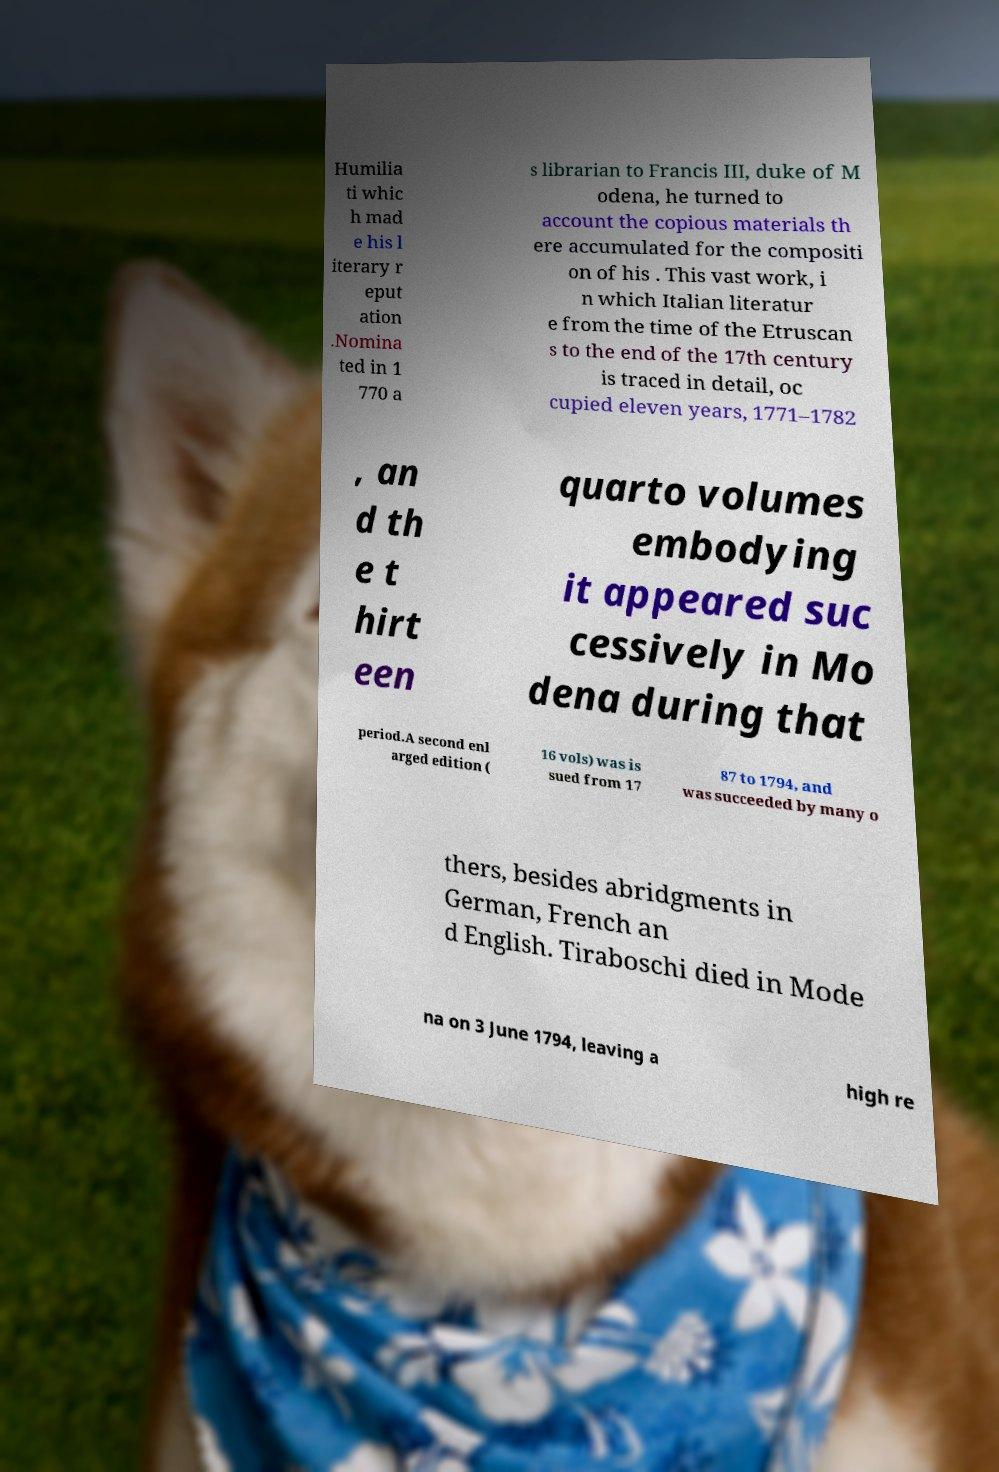Could you extract and type out the text from this image? Humilia ti whic h mad e his l iterary r eput ation .Nomina ted in 1 770 a s librarian to Francis III, duke of M odena, he turned to account the copious materials th ere accumulated for the compositi on of his . This vast work, i n which Italian literatur e from the time of the Etruscan s to the end of the 17th century is traced in detail, oc cupied eleven years, 1771–1782 , an d th e t hirt een quarto volumes embodying it appeared suc cessively in Mo dena during that period.A second enl arged edition ( 16 vols) was is sued from 17 87 to 1794, and was succeeded by many o thers, besides abridgments in German, French an d English. Tiraboschi died in Mode na on 3 June 1794, leaving a high re 